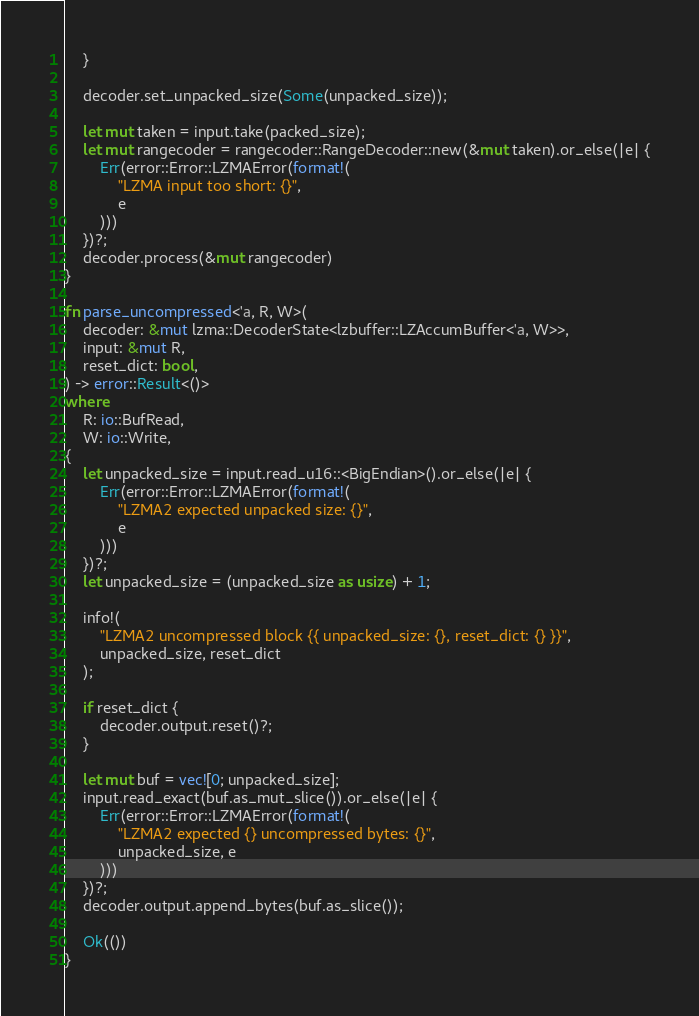<code> <loc_0><loc_0><loc_500><loc_500><_Rust_>    }

    decoder.set_unpacked_size(Some(unpacked_size));

    let mut taken = input.take(packed_size);
    let mut rangecoder = rangecoder::RangeDecoder::new(&mut taken).or_else(|e| {
        Err(error::Error::LZMAError(format!(
            "LZMA input too short: {}",
            e
        )))
    })?;
    decoder.process(&mut rangecoder)
}

fn parse_uncompressed<'a, R, W>(
    decoder: &mut lzma::DecoderState<lzbuffer::LZAccumBuffer<'a, W>>,
    input: &mut R,
    reset_dict: bool,
) -> error::Result<()>
where
    R: io::BufRead,
    W: io::Write,
{
    let unpacked_size = input.read_u16::<BigEndian>().or_else(|e| {
        Err(error::Error::LZMAError(format!(
            "LZMA2 expected unpacked size: {}",
            e
        )))
    })?;
    let unpacked_size = (unpacked_size as usize) + 1;

    info!(
        "LZMA2 uncompressed block {{ unpacked_size: {}, reset_dict: {} }}",
        unpacked_size, reset_dict
    );

    if reset_dict {
        decoder.output.reset()?;
    }

    let mut buf = vec![0; unpacked_size];
    input.read_exact(buf.as_mut_slice()).or_else(|e| {
        Err(error::Error::LZMAError(format!(
            "LZMA2 expected {} uncompressed bytes: {}",
            unpacked_size, e
        )))
    })?;
    decoder.output.append_bytes(buf.as_slice());

    Ok(())
}
</code> 